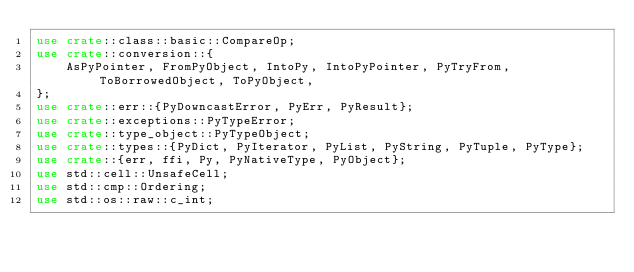<code> <loc_0><loc_0><loc_500><loc_500><_Rust_>use crate::class::basic::CompareOp;
use crate::conversion::{
    AsPyPointer, FromPyObject, IntoPy, IntoPyPointer, PyTryFrom, ToBorrowedObject, ToPyObject,
};
use crate::err::{PyDowncastError, PyErr, PyResult};
use crate::exceptions::PyTypeError;
use crate::type_object::PyTypeObject;
use crate::types::{PyDict, PyIterator, PyList, PyString, PyTuple, PyType};
use crate::{err, ffi, Py, PyNativeType, PyObject};
use std::cell::UnsafeCell;
use std::cmp::Ordering;
use std::os::raw::c_int;
</code> 